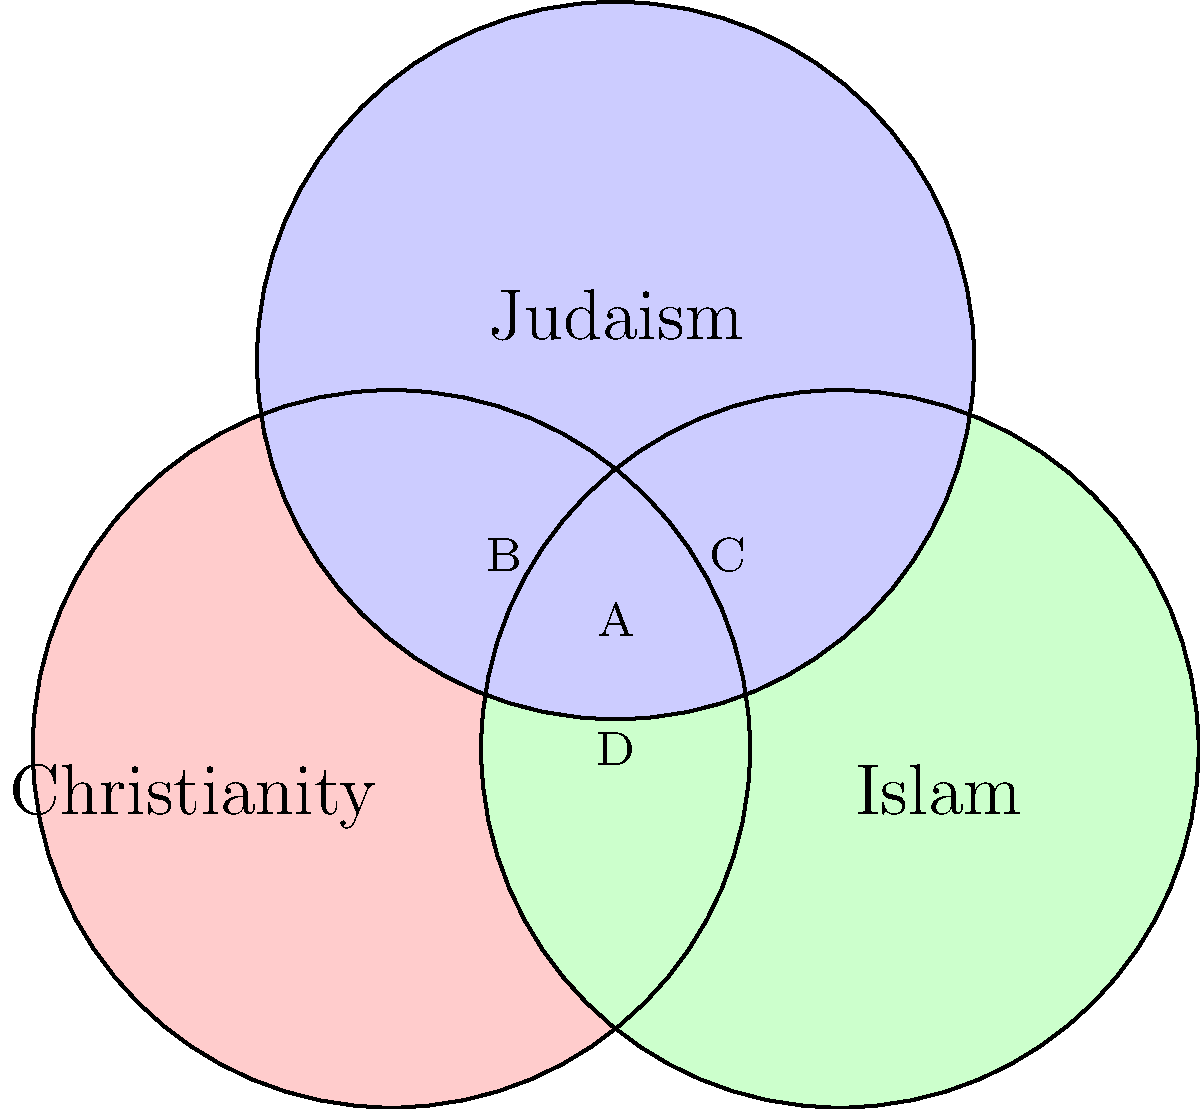In the Venn diagram representing the three Abrahamic religions, which area represents beliefs or practices that are unique to Christianity and not shared with either Islam or Judaism? To answer this question, let's analyze the Venn diagram step-by-step:

1. The diagram shows three overlapping circles representing Christianity, Islam, and Judaism.

2. Each circle represents the beliefs and practices of its respective religion.

3. The overlapping areas represent shared beliefs or practices between two or three religions.

4. The area we're looking for should be part of the Christianity circle but not overlapping with either Islam or Judaism.

5. Looking at the diagram:
   - Area A is shared by all three religions
   - Area B is shared by Christianity and Judaism
   - Area C is shared by Islam and Judaism
   - Area D is shared by Christianity and Islam

6. The only area that is part of the Christianity circle but not overlapping with the other two is the portion of the red circle that doesn't intersect with the green (Islam) or blue (Judaism) circles.

This area represents beliefs or practices that are unique to Christianity, such as the doctrine of the Trinity, the belief in Jesus as the incarnate Son of God, or the sacrament of the Eucharist.
Answer: The non-overlapping portion of the Christianity circle 